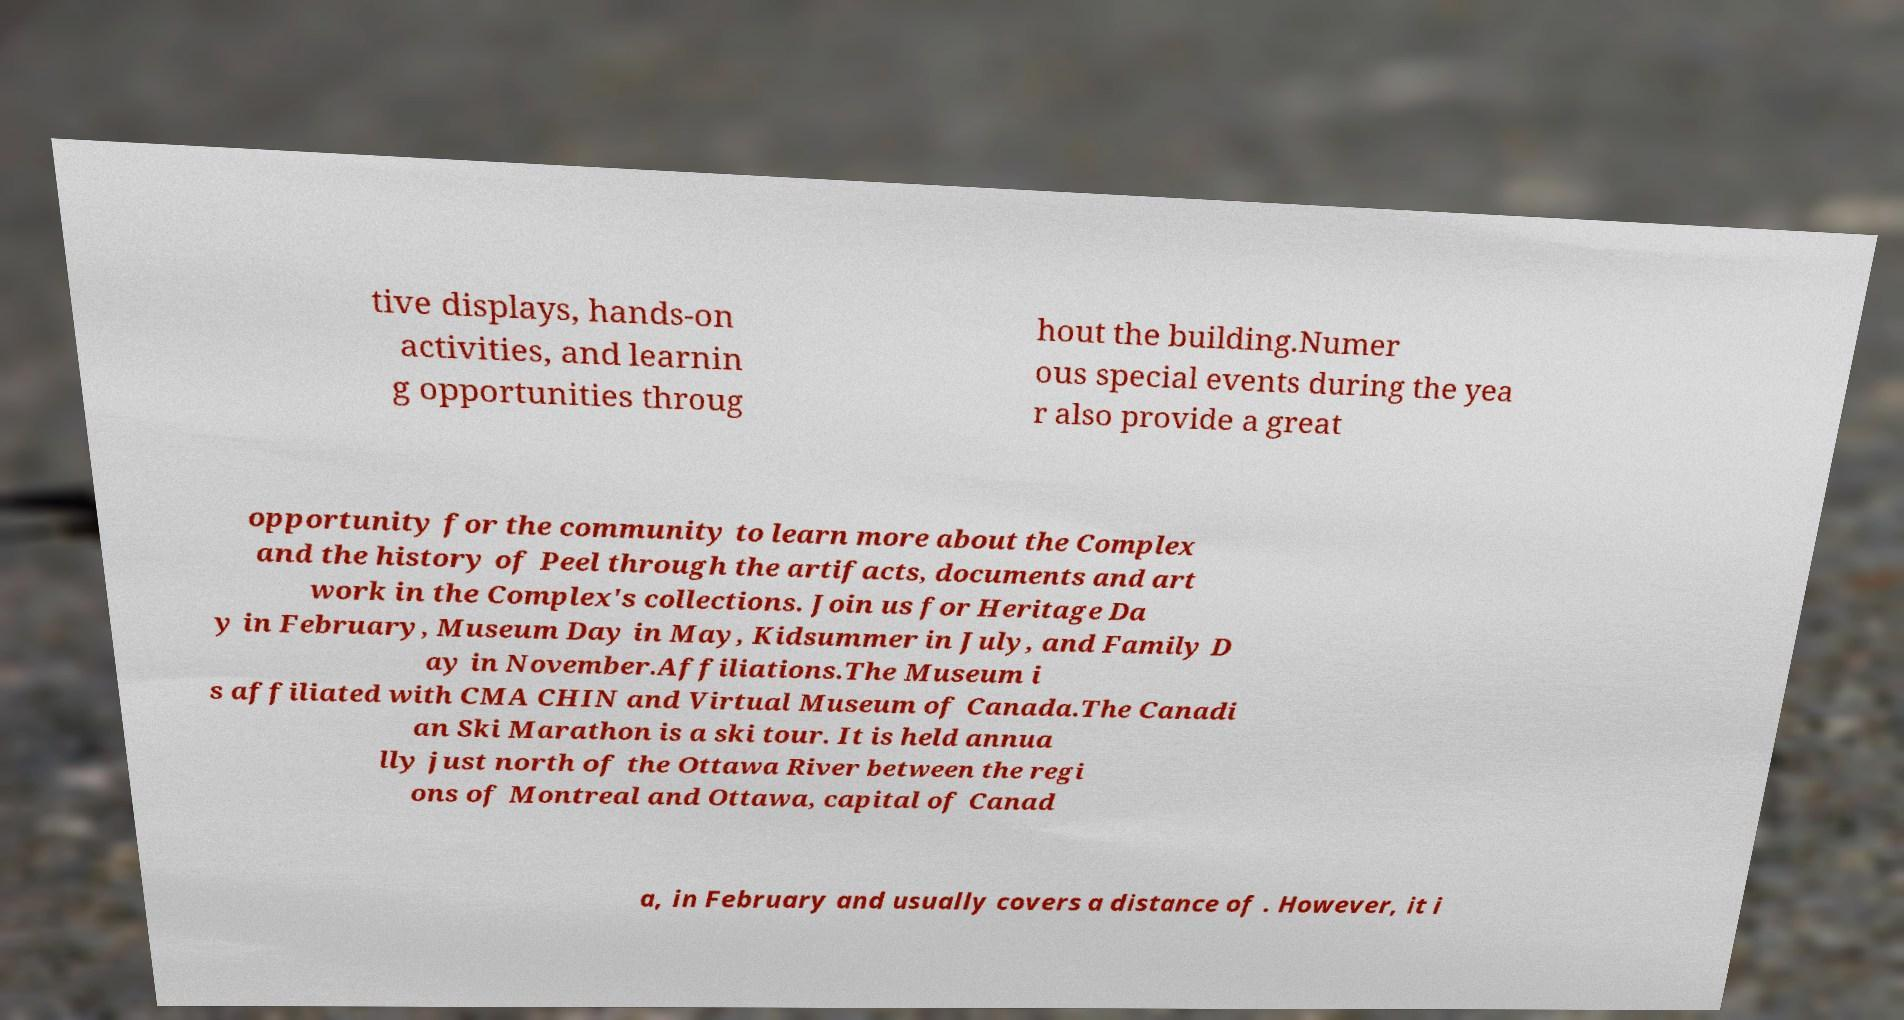What messages or text are displayed in this image? I need them in a readable, typed format. tive displays, hands-on activities, and learnin g opportunities throug hout the building.Numer ous special events during the yea r also provide a great opportunity for the community to learn more about the Complex and the history of Peel through the artifacts, documents and art work in the Complex's collections. Join us for Heritage Da y in February, Museum Day in May, Kidsummer in July, and Family D ay in November.Affiliations.The Museum i s affiliated with CMA CHIN and Virtual Museum of Canada.The Canadi an Ski Marathon is a ski tour. It is held annua lly just north of the Ottawa River between the regi ons of Montreal and Ottawa, capital of Canad a, in February and usually covers a distance of . However, it i 